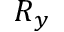Convert formula to latex. <formula><loc_0><loc_0><loc_500><loc_500>R _ { y }</formula> 